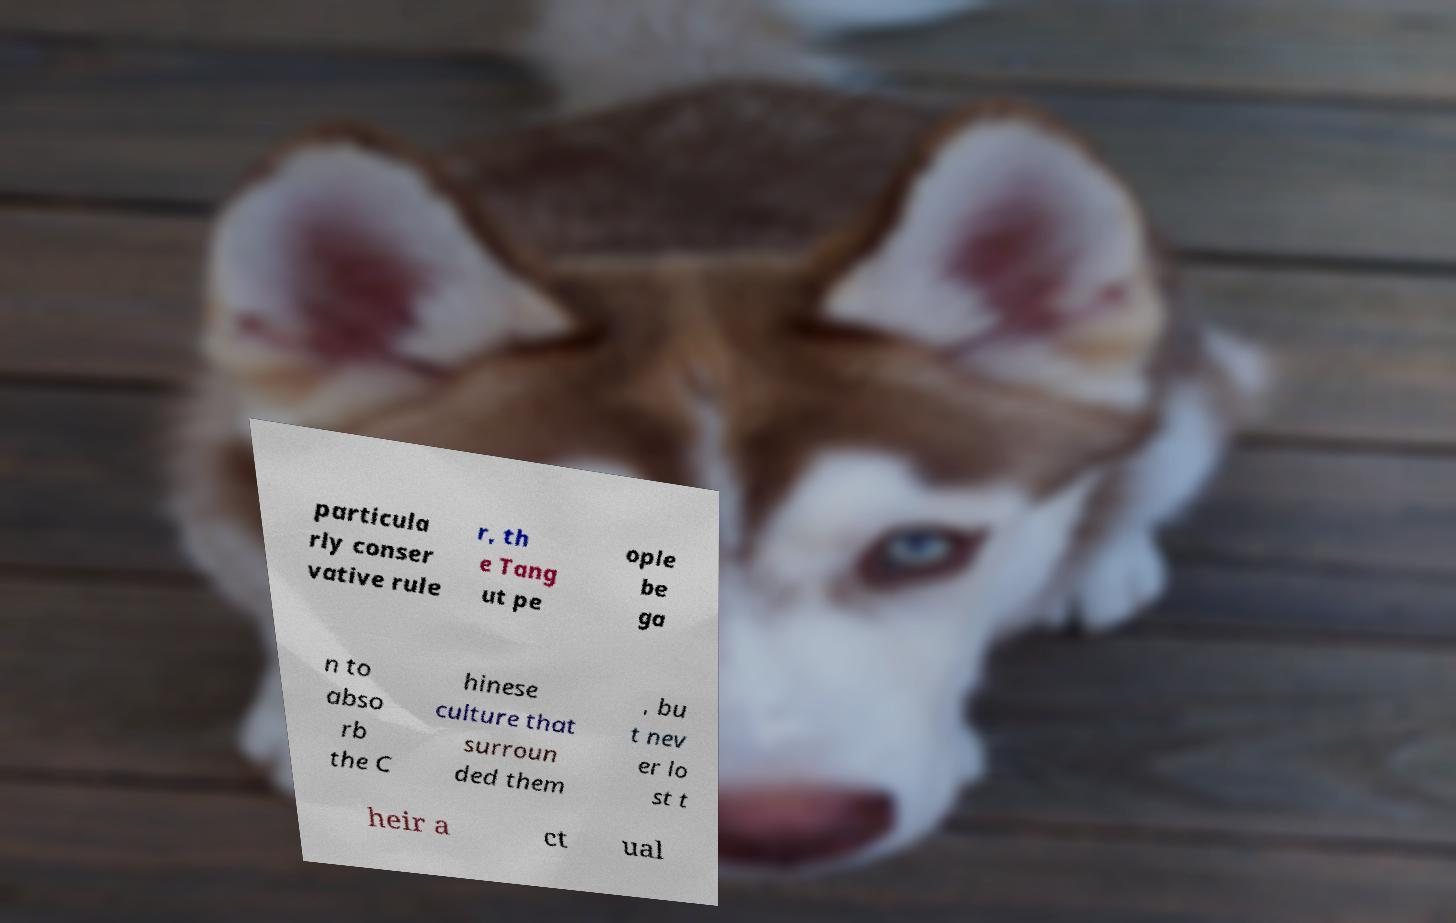I need the written content from this picture converted into text. Can you do that? particula rly conser vative rule r, th e Tang ut pe ople be ga n to abso rb the C hinese culture that surroun ded them , bu t nev er lo st t heir a ct ual 